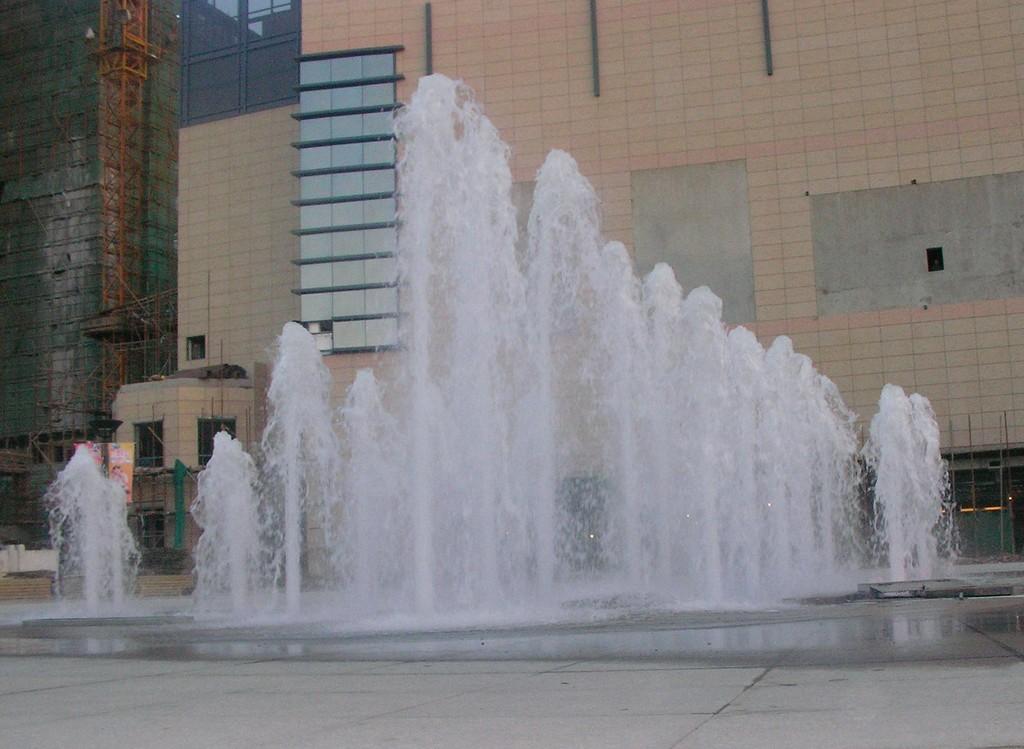Could you give a brief overview of what you see in this image? There is a water fountain. Behind that there is a building. On the left side there is a construction of the building. 